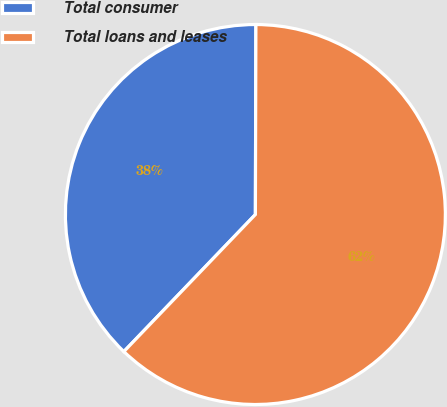Convert chart to OTSL. <chart><loc_0><loc_0><loc_500><loc_500><pie_chart><fcel>Total consumer<fcel>Total loans and leases<nl><fcel>37.87%<fcel>62.13%<nl></chart> 